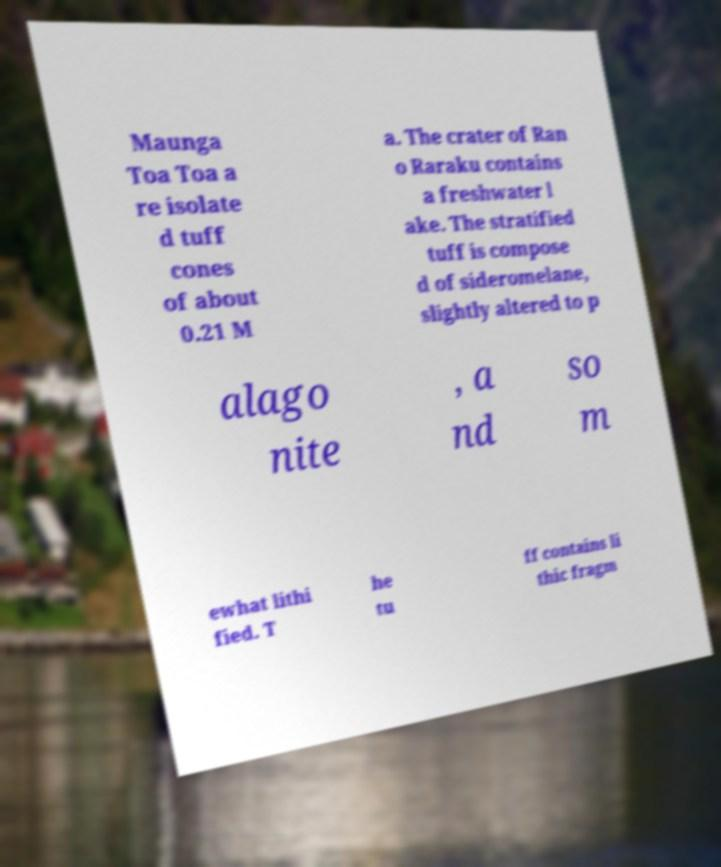Please read and relay the text visible in this image. What does it say? Maunga Toa Toa a re isolate d tuff cones of about 0.21 M a. The crater of Ran o Raraku contains a freshwater l ake. The stratified tuff is compose d of sideromelane, slightly altered to p alago nite , a nd so m ewhat lithi fied. T he tu ff contains li thic fragm 